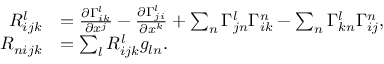<formula> <loc_0><loc_0><loc_500><loc_500>\begin{array} { r l } { R _ { i j k } ^ { l } } & { = \frac { \partial \Gamma _ { i k } ^ { l } } { \partial x ^ { j } } - \frac { \partial \Gamma _ { j i } ^ { l } } { \partial x ^ { k } } + \sum _ { n } \Gamma _ { j n } ^ { l } \Gamma _ { i k } ^ { n } - \sum _ { n } \Gamma _ { k n } ^ { l } \Gamma _ { i j } ^ { n } , } \\ { R _ { n i j k } } & { = \sum _ { l } R _ { i j k } ^ { l } g _ { \ln } . } \end{array}</formula> 